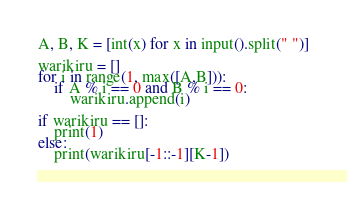<code> <loc_0><loc_0><loc_500><loc_500><_Python_>A, B, K = [int(x) for x in input().split(" ")]

warikiru = []
for i in range(1, max([A,B])):
    if A % i == 0 and B % i == 0:
        warikiru.append(i)

if warikiru == []:
    print(1)
else:
    print(warikiru[-1::-1][K-1])</code> 